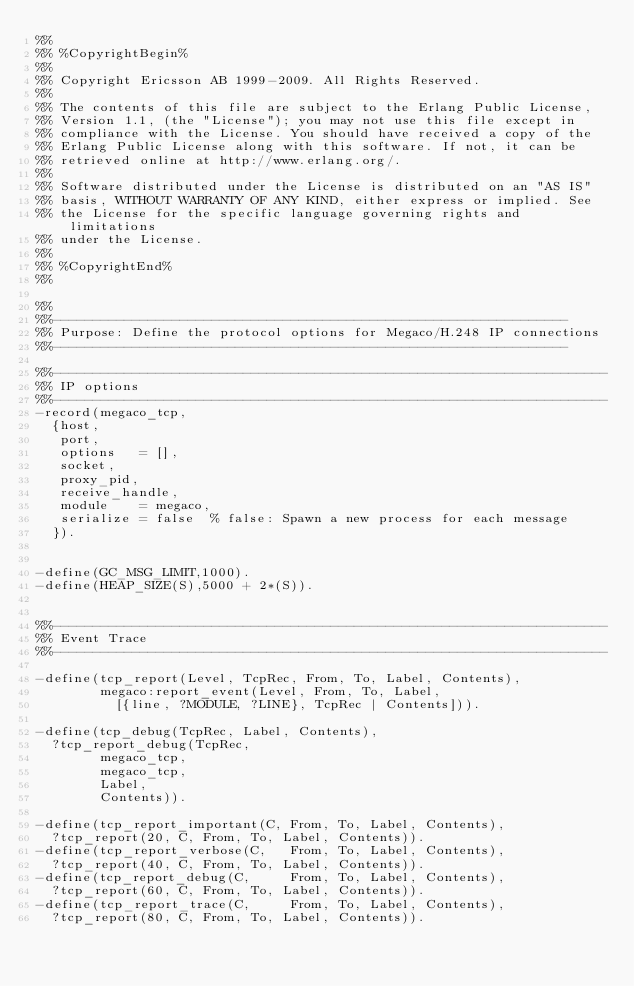<code> <loc_0><loc_0><loc_500><loc_500><_Erlang_>%%
%% %CopyrightBegin%
%% 
%% Copyright Ericsson AB 1999-2009. All Rights Reserved.
%% 
%% The contents of this file are subject to the Erlang Public License,
%% Version 1.1, (the "License"); you may not use this file except in
%% compliance with the License. You should have received a copy of the
%% Erlang Public License along with this software. If not, it can be
%% retrieved online at http://www.erlang.org/.
%% 
%% Software distributed under the License is distributed on an "AS IS"
%% basis, WITHOUT WARRANTY OF ANY KIND, either express or implied. See
%% the License for the specific language governing rights and limitations
%% under the License.
%% 
%% %CopyrightEnd%
%%

%%
%%-----------------------------------------------------------------
%% Purpose: Define the protocol options for Megaco/H.248 IP connections
%%-----------------------------------------------------------------

%%----------------------------------------------------------------------
%% IP options
%%----------------------------------------------------------------------
-record(megaco_tcp,
	{host,
	 port,
	 options   = [],
	 socket,
	 proxy_pid,
	 receive_handle,
	 module    = megaco,
	 serialize = false  % false: Spawn a new process for each message
	}).


-define(GC_MSG_LIMIT,1000).
-define(HEAP_SIZE(S),5000 + 2*(S)).


%%----------------------------------------------------------------------
%% Event Trace
%%----------------------------------------------------------------------

-define(tcp_report(Level, TcpRec, From, To, Label, Contents),
        megaco:report_event(Level, From, To, Label,
			    [{line, ?MODULE, ?LINE}, TcpRec | Contents])).

-define(tcp_debug(TcpRec, Label, Contents),
	?tcp_report_debug(TcpRec,
			  megaco_tcp,
			  megaco_tcp,
			  Label,
			  Contents)).

-define(tcp_report_important(C, From, To, Label, Contents), 
	?tcp_report(20, C, From, To, Label, Contents)).
-define(tcp_report_verbose(C,   From, To, Label, Contents), 
	?tcp_report(40, C, From, To, Label, Contents)).
-define(tcp_report_debug(C,     From, To, Label, Contents), 
	?tcp_report(60, C, From, To, Label, Contents)).
-define(tcp_report_trace(C,     From, To, Label, Contents), 
	?tcp_report(80, C, From, To, Label, Contents)).


</code> 